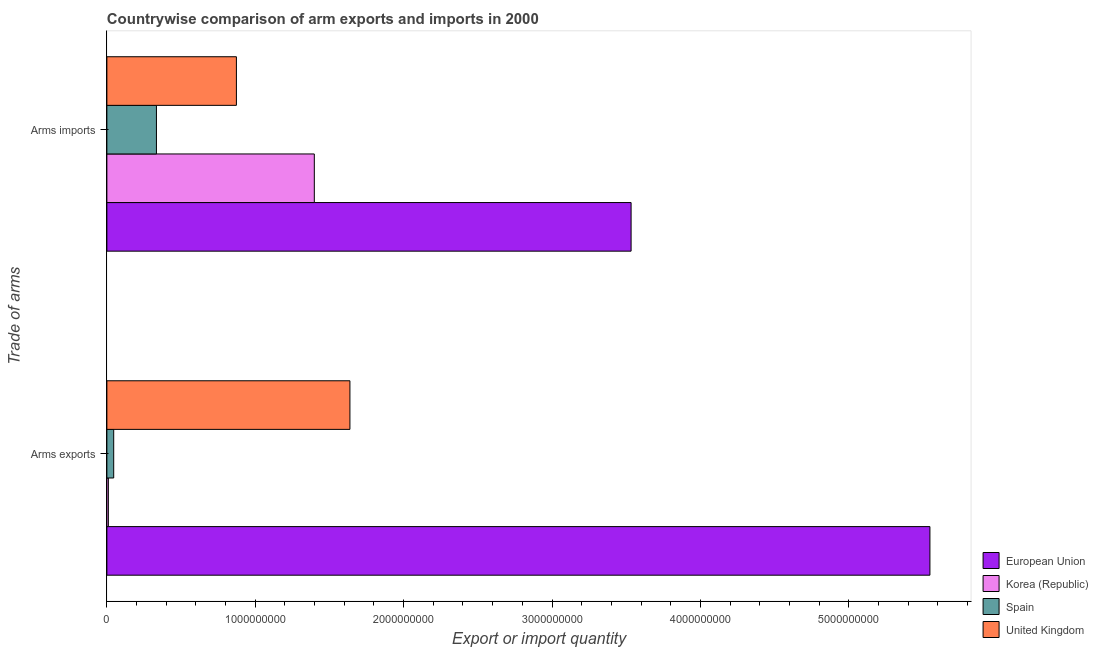How many different coloured bars are there?
Make the answer very short. 4. How many groups of bars are there?
Your response must be concise. 2. Are the number of bars per tick equal to the number of legend labels?
Your answer should be very brief. Yes. Are the number of bars on each tick of the Y-axis equal?
Your answer should be very brief. Yes. How many bars are there on the 1st tick from the top?
Give a very brief answer. 4. How many bars are there on the 2nd tick from the bottom?
Provide a short and direct response. 4. What is the label of the 1st group of bars from the top?
Provide a succinct answer. Arms imports. What is the arms exports in Korea (Republic)?
Make the answer very short. 1.00e+07. Across all countries, what is the maximum arms imports?
Your response must be concise. 3.53e+09. Across all countries, what is the minimum arms imports?
Your answer should be compact. 3.34e+08. In which country was the arms exports maximum?
Your response must be concise. European Union. In which country was the arms imports minimum?
Offer a very short reply. Spain. What is the total arms imports in the graph?
Provide a succinct answer. 6.14e+09. What is the difference between the arms imports in Korea (Republic) and that in European Union?
Give a very brief answer. -2.14e+09. What is the difference between the arms exports in Spain and the arms imports in Korea (Republic)?
Provide a succinct answer. -1.35e+09. What is the average arms imports per country?
Your response must be concise. 1.53e+09. What is the difference between the arms imports and arms exports in European Union?
Provide a short and direct response. -2.01e+09. In how many countries, is the arms imports greater than 200000000 ?
Ensure brevity in your answer.  4. What is the ratio of the arms imports in Spain to that in European Union?
Make the answer very short. 0.09. Is the arms imports in Korea (Republic) less than that in Spain?
Ensure brevity in your answer.  No. What does the 3rd bar from the top in Arms imports represents?
Your answer should be very brief. Korea (Republic). What does the 2nd bar from the bottom in Arms imports represents?
Make the answer very short. Korea (Republic). Are all the bars in the graph horizontal?
Your answer should be compact. Yes. Are the values on the major ticks of X-axis written in scientific E-notation?
Provide a short and direct response. No. Where does the legend appear in the graph?
Your response must be concise. Bottom right. How many legend labels are there?
Ensure brevity in your answer.  4. How are the legend labels stacked?
Keep it short and to the point. Vertical. What is the title of the graph?
Your answer should be compact. Countrywise comparison of arm exports and imports in 2000. Does "Australia" appear as one of the legend labels in the graph?
Provide a succinct answer. No. What is the label or title of the X-axis?
Your answer should be very brief. Export or import quantity. What is the label or title of the Y-axis?
Ensure brevity in your answer.  Trade of arms. What is the Export or import quantity in European Union in Arms exports?
Provide a succinct answer. 5.55e+09. What is the Export or import quantity of Spain in Arms exports?
Your answer should be compact. 4.60e+07. What is the Export or import quantity of United Kingdom in Arms exports?
Give a very brief answer. 1.64e+09. What is the Export or import quantity of European Union in Arms imports?
Offer a very short reply. 3.53e+09. What is the Export or import quantity of Korea (Republic) in Arms imports?
Provide a short and direct response. 1.40e+09. What is the Export or import quantity of Spain in Arms imports?
Provide a short and direct response. 3.34e+08. What is the Export or import quantity of United Kingdom in Arms imports?
Offer a terse response. 8.73e+08. Across all Trade of arms, what is the maximum Export or import quantity of European Union?
Make the answer very short. 5.55e+09. Across all Trade of arms, what is the maximum Export or import quantity in Korea (Republic)?
Provide a short and direct response. 1.40e+09. Across all Trade of arms, what is the maximum Export or import quantity of Spain?
Keep it short and to the point. 3.34e+08. Across all Trade of arms, what is the maximum Export or import quantity in United Kingdom?
Provide a succinct answer. 1.64e+09. Across all Trade of arms, what is the minimum Export or import quantity in European Union?
Keep it short and to the point. 3.53e+09. Across all Trade of arms, what is the minimum Export or import quantity of Korea (Republic)?
Your response must be concise. 1.00e+07. Across all Trade of arms, what is the minimum Export or import quantity in Spain?
Give a very brief answer. 4.60e+07. Across all Trade of arms, what is the minimum Export or import quantity of United Kingdom?
Ensure brevity in your answer.  8.73e+08. What is the total Export or import quantity of European Union in the graph?
Keep it short and to the point. 9.08e+09. What is the total Export or import quantity of Korea (Republic) in the graph?
Offer a very short reply. 1.41e+09. What is the total Export or import quantity in Spain in the graph?
Give a very brief answer. 3.80e+08. What is the total Export or import quantity in United Kingdom in the graph?
Your answer should be very brief. 2.51e+09. What is the difference between the Export or import quantity in European Union in Arms exports and that in Arms imports?
Ensure brevity in your answer.  2.01e+09. What is the difference between the Export or import quantity of Korea (Republic) in Arms exports and that in Arms imports?
Offer a very short reply. -1.39e+09. What is the difference between the Export or import quantity in Spain in Arms exports and that in Arms imports?
Your answer should be very brief. -2.88e+08. What is the difference between the Export or import quantity in United Kingdom in Arms exports and that in Arms imports?
Provide a short and direct response. 7.65e+08. What is the difference between the Export or import quantity in European Union in Arms exports and the Export or import quantity in Korea (Republic) in Arms imports?
Give a very brief answer. 4.15e+09. What is the difference between the Export or import quantity in European Union in Arms exports and the Export or import quantity in Spain in Arms imports?
Ensure brevity in your answer.  5.21e+09. What is the difference between the Export or import quantity in European Union in Arms exports and the Export or import quantity in United Kingdom in Arms imports?
Make the answer very short. 4.67e+09. What is the difference between the Export or import quantity in Korea (Republic) in Arms exports and the Export or import quantity in Spain in Arms imports?
Give a very brief answer. -3.24e+08. What is the difference between the Export or import quantity in Korea (Republic) in Arms exports and the Export or import quantity in United Kingdom in Arms imports?
Make the answer very short. -8.63e+08. What is the difference between the Export or import quantity of Spain in Arms exports and the Export or import quantity of United Kingdom in Arms imports?
Give a very brief answer. -8.27e+08. What is the average Export or import quantity in European Union per Trade of arms?
Give a very brief answer. 4.54e+09. What is the average Export or import quantity of Korea (Republic) per Trade of arms?
Give a very brief answer. 7.04e+08. What is the average Export or import quantity in Spain per Trade of arms?
Provide a short and direct response. 1.90e+08. What is the average Export or import quantity in United Kingdom per Trade of arms?
Give a very brief answer. 1.26e+09. What is the difference between the Export or import quantity in European Union and Export or import quantity in Korea (Republic) in Arms exports?
Make the answer very short. 5.54e+09. What is the difference between the Export or import quantity in European Union and Export or import quantity in Spain in Arms exports?
Keep it short and to the point. 5.50e+09. What is the difference between the Export or import quantity in European Union and Export or import quantity in United Kingdom in Arms exports?
Offer a terse response. 3.91e+09. What is the difference between the Export or import quantity in Korea (Republic) and Export or import quantity in Spain in Arms exports?
Your response must be concise. -3.60e+07. What is the difference between the Export or import quantity of Korea (Republic) and Export or import quantity of United Kingdom in Arms exports?
Offer a very short reply. -1.63e+09. What is the difference between the Export or import quantity of Spain and Export or import quantity of United Kingdom in Arms exports?
Offer a very short reply. -1.59e+09. What is the difference between the Export or import quantity in European Union and Export or import quantity in Korea (Republic) in Arms imports?
Ensure brevity in your answer.  2.14e+09. What is the difference between the Export or import quantity in European Union and Export or import quantity in Spain in Arms imports?
Make the answer very short. 3.20e+09. What is the difference between the Export or import quantity of European Union and Export or import quantity of United Kingdom in Arms imports?
Provide a short and direct response. 2.66e+09. What is the difference between the Export or import quantity in Korea (Republic) and Export or import quantity in Spain in Arms imports?
Offer a very short reply. 1.06e+09. What is the difference between the Export or import quantity in Korea (Republic) and Export or import quantity in United Kingdom in Arms imports?
Your response must be concise. 5.25e+08. What is the difference between the Export or import quantity in Spain and Export or import quantity in United Kingdom in Arms imports?
Make the answer very short. -5.39e+08. What is the ratio of the Export or import quantity in European Union in Arms exports to that in Arms imports?
Your response must be concise. 1.57. What is the ratio of the Export or import quantity in Korea (Republic) in Arms exports to that in Arms imports?
Keep it short and to the point. 0.01. What is the ratio of the Export or import quantity in Spain in Arms exports to that in Arms imports?
Give a very brief answer. 0.14. What is the ratio of the Export or import quantity of United Kingdom in Arms exports to that in Arms imports?
Your answer should be very brief. 1.88. What is the difference between the highest and the second highest Export or import quantity of European Union?
Make the answer very short. 2.01e+09. What is the difference between the highest and the second highest Export or import quantity of Korea (Republic)?
Provide a succinct answer. 1.39e+09. What is the difference between the highest and the second highest Export or import quantity in Spain?
Give a very brief answer. 2.88e+08. What is the difference between the highest and the second highest Export or import quantity of United Kingdom?
Offer a terse response. 7.65e+08. What is the difference between the highest and the lowest Export or import quantity in European Union?
Keep it short and to the point. 2.01e+09. What is the difference between the highest and the lowest Export or import quantity in Korea (Republic)?
Provide a succinct answer. 1.39e+09. What is the difference between the highest and the lowest Export or import quantity of Spain?
Provide a succinct answer. 2.88e+08. What is the difference between the highest and the lowest Export or import quantity of United Kingdom?
Your answer should be compact. 7.65e+08. 